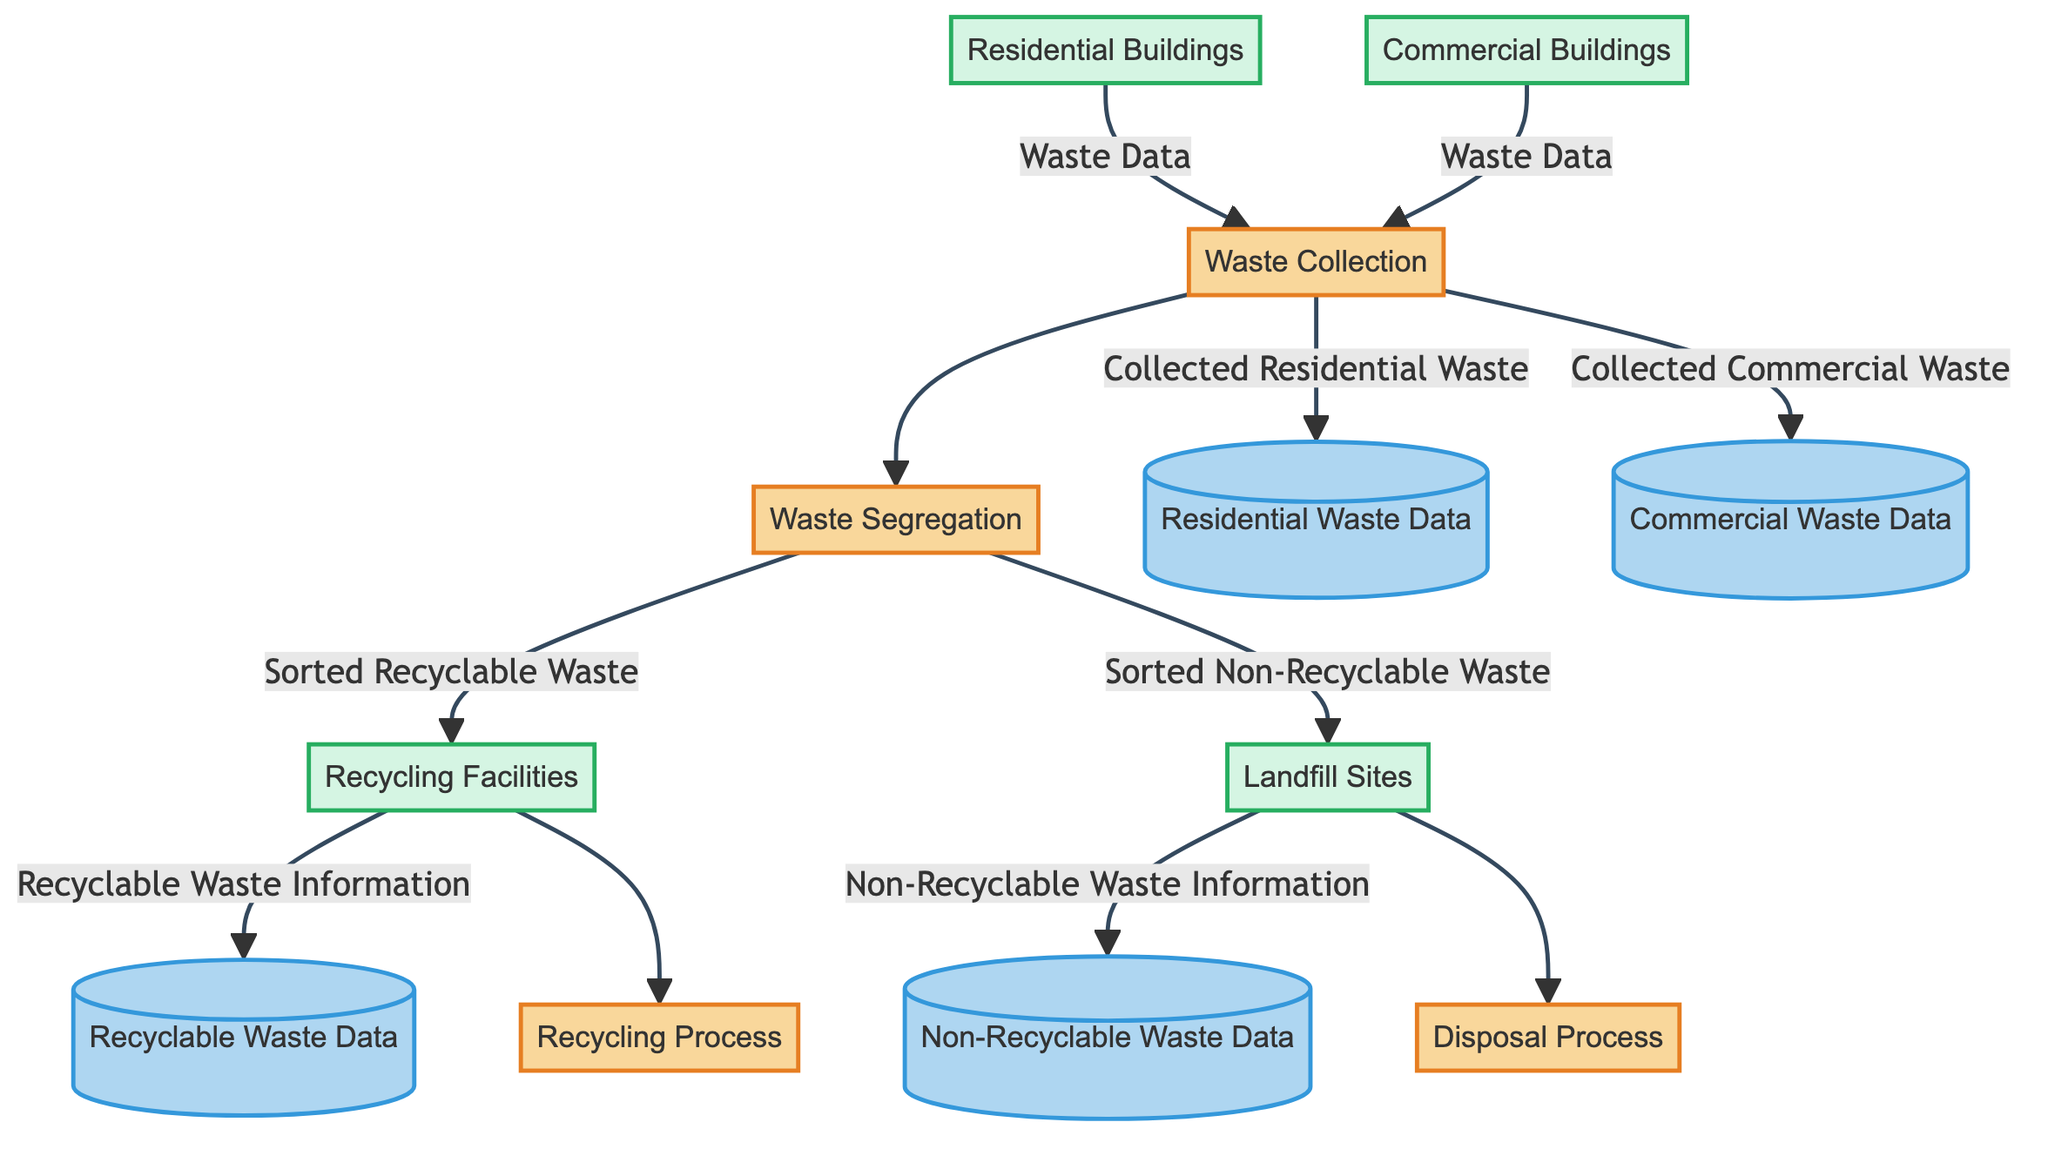What is the first process in the waste management workflow? The diagram indicates that "Waste Collection" is the first process, as it is the initial step in collecting waste from residential and commercial buildings.
Answer: Waste Collection How many external entities are present in the diagram? By counting the nodes categorized as external entities, we have "Residential Buildings," "Commercial Buildings," "Recycling Facilities," and "Landfill Sites," totaling four external entities.
Answer: 4 Which data store receives information from the "Recycling Facilities"? The diagram shows that "Recyclable Waste Data" is the data store that receives information from "Recycling Facilities" through the data flow labeled "Recyclable Waste Information."
Answer: Recyclable Waste Data What type of waste is sorted and sent to Landfill Sites? The data flow labeled "Sorted Non-Recyclable Waste" indicates that non-recyclable waste is sorted and sent to Landfill Sites.
Answer: Non-Recyclable Waste Which two processes are connected directly after waste is collected? The flow proceeds from "Waste Collection" to "Waste Segregation," indicating that these two processes are directly connected following the waste collection stage.
Answer: Waste Segregation Which external entity is the source of commercial waste? "Commercial Buildings" is specified in the diagram as the external entity that sources commercial waste data, indicated by the data flow labeled "Waste Data."
Answer: Commercial Buildings What data does "Waste Segregation" send to "Recycling Facilities"? The "Sorted Recyclable Waste" data flow from "Waste Segregation" to "Recycling Facilities" denotes the specific information sent for processing of recyclable materials.
Answer: Sorted Recyclable Waste How is non-recyclable waste processed according to the diagram? The "Disposal Process" indicates that non-recyclable waste is processed, identified through the connection from "Waste Segregation" to "Landfill Sites," where non-recyclable waste is disposed of.
Answer: Disposal Process What is the last step in the waste management workflow? The "Disposal Process" represents the last step in managing waste, as it processes non-recyclable materials.
Answer: Disposal Process 